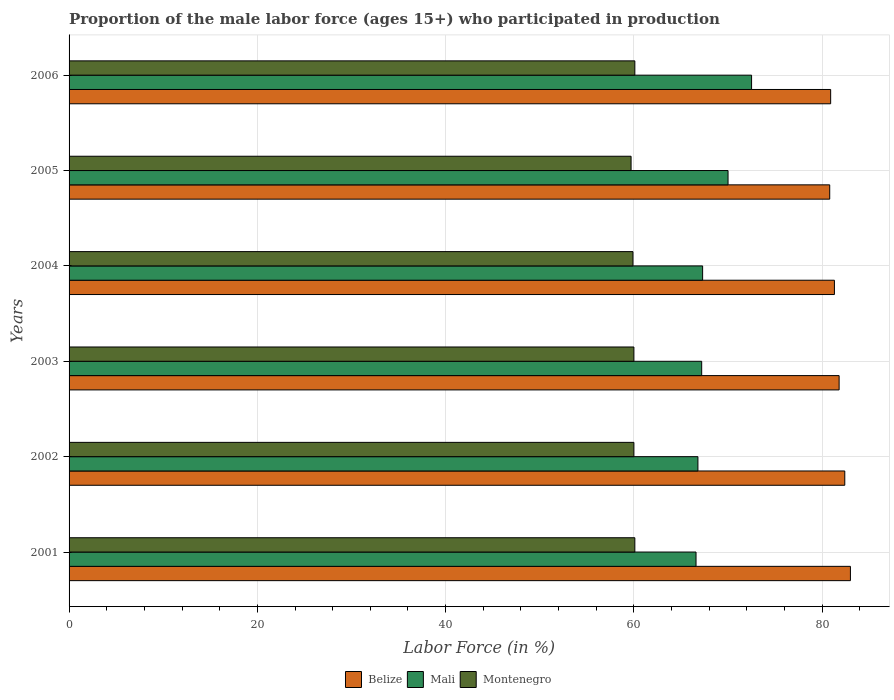Are the number of bars on each tick of the Y-axis equal?
Your response must be concise. Yes. How many bars are there on the 3rd tick from the top?
Give a very brief answer. 3. In how many cases, is the number of bars for a given year not equal to the number of legend labels?
Offer a very short reply. 0. What is the proportion of the male labor force who participated in production in Montenegro in 2005?
Keep it short and to the point. 59.7. Across all years, what is the maximum proportion of the male labor force who participated in production in Mali?
Your answer should be very brief. 72.5. Across all years, what is the minimum proportion of the male labor force who participated in production in Montenegro?
Your answer should be compact. 59.7. In which year was the proportion of the male labor force who participated in production in Belize maximum?
Your answer should be very brief. 2001. In which year was the proportion of the male labor force who participated in production in Belize minimum?
Keep it short and to the point. 2005. What is the total proportion of the male labor force who participated in production in Montenegro in the graph?
Provide a succinct answer. 359.8. What is the difference between the proportion of the male labor force who participated in production in Mali in 2002 and that in 2003?
Offer a terse response. -0.4. What is the difference between the proportion of the male labor force who participated in production in Mali in 2003 and the proportion of the male labor force who participated in production in Belize in 2002?
Provide a short and direct response. -15.2. What is the average proportion of the male labor force who participated in production in Belize per year?
Keep it short and to the point. 81.7. In the year 2004, what is the difference between the proportion of the male labor force who participated in production in Mali and proportion of the male labor force who participated in production in Belize?
Keep it short and to the point. -14. In how many years, is the proportion of the male labor force who participated in production in Mali greater than 40 %?
Give a very brief answer. 6. What is the ratio of the proportion of the male labor force who participated in production in Mali in 2003 to that in 2004?
Offer a very short reply. 1. Is the proportion of the male labor force who participated in production in Mali in 2001 less than that in 2004?
Provide a succinct answer. Yes. What is the difference between the highest and the second highest proportion of the male labor force who participated in production in Montenegro?
Provide a succinct answer. 0. What is the difference between the highest and the lowest proportion of the male labor force who participated in production in Montenegro?
Ensure brevity in your answer.  0.4. In how many years, is the proportion of the male labor force who participated in production in Montenegro greater than the average proportion of the male labor force who participated in production in Montenegro taken over all years?
Provide a short and direct response. 4. What does the 1st bar from the top in 2005 represents?
Offer a very short reply. Montenegro. What does the 3rd bar from the bottom in 2001 represents?
Offer a terse response. Montenegro. How many years are there in the graph?
Offer a very short reply. 6. How are the legend labels stacked?
Keep it short and to the point. Horizontal. What is the title of the graph?
Offer a terse response. Proportion of the male labor force (ages 15+) who participated in production. What is the label or title of the X-axis?
Provide a short and direct response. Labor Force (in %). What is the Labor Force (in %) of Mali in 2001?
Keep it short and to the point. 66.6. What is the Labor Force (in %) of Montenegro in 2001?
Keep it short and to the point. 60.1. What is the Labor Force (in %) of Belize in 2002?
Your answer should be very brief. 82.4. What is the Labor Force (in %) in Mali in 2002?
Keep it short and to the point. 66.8. What is the Labor Force (in %) of Belize in 2003?
Give a very brief answer. 81.8. What is the Labor Force (in %) in Mali in 2003?
Give a very brief answer. 67.2. What is the Labor Force (in %) in Belize in 2004?
Provide a succinct answer. 81.3. What is the Labor Force (in %) in Mali in 2004?
Make the answer very short. 67.3. What is the Labor Force (in %) in Montenegro in 2004?
Your response must be concise. 59.9. What is the Labor Force (in %) in Belize in 2005?
Offer a terse response. 80.8. What is the Labor Force (in %) in Montenegro in 2005?
Make the answer very short. 59.7. What is the Labor Force (in %) in Belize in 2006?
Provide a succinct answer. 80.9. What is the Labor Force (in %) of Mali in 2006?
Provide a succinct answer. 72.5. What is the Labor Force (in %) in Montenegro in 2006?
Offer a very short reply. 60.1. Across all years, what is the maximum Labor Force (in %) in Belize?
Give a very brief answer. 83. Across all years, what is the maximum Labor Force (in %) of Mali?
Provide a succinct answer. 72.5. Across all years, what is the maximum Labor Force (in %) in Montenegro?
Provide a short and direct response. 60.1. Across all years, what is the minimum Labor Force (in %) of Belize?
Keep it short and to the point. 80.8. Across all years, what is the minimum Labor Force (in %) of Mali?
Offer a very short reply. 66.6. Across all years, what is the minimum Labor Force (in %) of Montenegro?
Offer a terse response. 59.7. What is the total Labor Force (in %) in Belize in the graph?
Provide a succinct answer. 490.2. What is the total Labor Force (in %) in Mali in the graph?
Offer a terse response. 410.4. What is the total Labor Force (in %) in Montenegro in the graph?
Your answer should be very brief. 359.8. What is the difference between the Labor Force (in %) in Mali in 2001 and that in 2002?
Ensure brevity in your answer.  -0.2. What is the difference between the Labor Force (in %) of Belize in 2001 and that in 2003?
Your answer should be compact. 1.2. What is the difference between the Labor Force (in %) of Mali in 2001 and that in 2003?
Offer a very short reply. -0.6. What is the difference between the Labor Force (in %) in Mali in 2001 and that in 2004?
Give a very brief answer. -0.7. What is the difference between the Labor Force (in %) in Belize in 2001 and that in 2005?
Give a very brief answer. 2.2. What is the difference between the Labor Force (in %) in Mali in 2001 and that in 2005?
Give a very brief answer. -3.4. What is the difference between the Labor Force (in %) of Mali in 2001 and that in 2006?
Provide a short and direct response. -5.9. What is the difference between the Labor Force (in %) of Montenegro in 2001 and that in 2006?
Your answer should be very brief. 0. What is the difference between the Labor Force (in %) in Belize in 2002 and that in 2005?
Your answer should be very brief. 1.6. What is the difference between the Labor Force (in %) of Mali in 2002 and that in 2006?
Make the answer very short. -5.7. What is the difference between the Labor Force (in %) in Montenegro in 2002 and that in 2006?
Offer a terse response. -0.1. What is the difference between the Labor Force (in %) of Mali in 2003 and that in 2004?
Offer a terse response. -0.1. What is the difference between the Labor Force (in %) in Montenegro in 2003 and that in 2004?
Give a very brief answer. 0.1. What is the difference between the Labor Force (in %) in Belize in 2003 and that in 2005?
Provide a succinct answer. 1. What is the difference between the Labor Force (in %) of Montenegro in 2003 and that in 2005?
Provide a short and direct response. 0.3. What is the difference between the Labor Force (in %) of Belize in 2003 and that in 2006?
Your answer should be very brief. 0.9. What is the difference between the Labor Force (in %) of Belize in 2004 and that in 2005?
Offer a terse response. 0.5. What is the difference between the Labor Force (in %) of Mali in 2004 and that in 2005?
Give a very brief answer. -2.7. What is the difference between the Labor Force (in %) of Belize in 2004 and that in 2006?
Your response must be concise. 0.4. What is the difference between the Labor Force (in %) in Montenegro in 2005 and that in 2006?
Offer a very short reply. -0.4. What is the difference between the Labor Force (in %) of Mali in 2001 and the Labor Force (in %) of Montenegro in 2002?
Your answer should be compact. 6.6. What is the difference between the Labor Force (in %) of Belize in 2001 and the Labor Force (in %) of Mali in 2003?
Give a very brief answer. 15.8. What is the difference between the Labor Force (in %) in Belize in 2001 and the Labor Force (in %) in Mali in 2004?
Keep it short and to the point. 15.7. What is the difference between the Labor Force (in %) of Belize in 2001 and the Labor Force (in %) of Montenegro in 2004?
Ensure brevity in your answer.  23.1. What is the difference between the Labor Force (in %) of Mali in 2001 and the Labor Force (in %) of Montenegro in 2004?
Offer a terse response. 6.7. What is the difference between the Labor Force (in %) of Belize in 2001 and the Labor Force (in %) of Mali in 2005?
Your answer should be compact. 13. What is the difference between the Labor Force (in %) of Belize in 2001 and the Labor Force (in %) of Montenegro in 2005?
Make the answer very short. 23.3. What is the difference between the Labor Force (in %) of Belize in 2001 and the Labor Force (in %) of Mali in 2006?
Your response must be concise. 10.5. What is the difference between the Labor Force (in %) of Belize in 2001 and the Labor Force (in %) of Montenegro in 2006?
Ensure brevity in your answer.  22.9. What is the difference between the Labor Force (in %) in Belize in 2002 and the Labor Force (in %) in Mali in 2003?
Make the answer very short. 15.2. What is the difference between the Labor Force (in %) in Belize in 2002 and the Labor Force (in %) in Montenegro in 2003?
Make the answer very short. 22.4. What is the difference between the Labor Force (in %) of Mali in 2002 and the Labor Force (in %) of Montenegro in 2003?
Offer a terse response. 6.8. What is the difference between the Labor Force (in %) of Belize in 2002 and the Labor Force (in %) of Mali in 2004?
Make the answer very short. 15.1. What is the difference between the Labor Force (in %) in Belize in 2002 and the Labor Force (in %) in Montenegro in 2004?
Provide a succinct answer. 22.5. What is the difference between the Labor Force (in %) of Belize in 2002 and the Labor Force (in %) of Mali in 2005?
Your answer should be very brief. 12.4. What is the difference between the Labor Force (in %) in Belize in 2002 and the Labor Force (in %) in Montenegro in 2005?
Provide a short and direct response. 22.7. What is the difference between the Labor Force (in %) of Mali in 2002 and the Labor Force (in %) of Montenegro in 2005?
Your answer should be compact. 7.1. What is the difference between the Labor Force (in %) in Belize in 2002 and the Labor Force (in %) in Mali in 2006?
Offer a very short reply. 9.9. What is the difference between the Labor Force (in %) in Belize in 2002 and the Labor Force (in %) in Montenegro in 2006?
Provide a succinct answer. 22.3. What is the difference between the Labor Force (in %) in Mali in 2002 and the Labor Force (in %) in Montenegro in 2006?
Provide a succinct answer. 6.7. What is the difference between the Labor Force (in %) in Belize in 2003 and the Labor Force (in %) in Montenegro in 2004?
Give a very brief answer. 21.9. What is the difference between the Labor Force (in %) in Mali in 2003 and the Labor Force (in %) in Montenegro in 2004?
Your answer should be very brief. 7.3. What is the difference between the Labor Force (in %) in Belize in 2003 and the Labor Force (in %) in Montenegro in 2005?
Provide a short and direct response. 22.1. What is the difference between the Labor Force (in %) in Belize in 2003 and the Labor Force (in %) in Mali in 2006?
Ensure brevity in your answer.  9.3. What is the difference between the Labor Force (in %) of Belize in 2003 and the Labor Force (in %) of Montenegro in 2006?
Provide a short and direct response. 21.7. What is the difference between the Labor Force (in %) of Belize in 2004 and the Labor Force (in %) of Montenegro in 2005?
Give a very brief answer. 21.6. What is the difference between the Labor Force (in %) in Belize in 2004 and the Labor Force (in %) in Montenegro in 2006?
Ensure brevity in your answer.  21.2. What is the difference between the Labor Force (in %) of Mali in 2004 and the Labor Force (in %) of Montenegro in 2006?
Provide a succinct answer. 7.2. What is the difference between the Labor Force (in %) in Belize in 2005 and the Labor Force (in %) in Montenegro in 2006?
Give a very brief answer. 20.7. What is the difference between the Labor Force (in %) of Mali in 2005 and the Labor Force (in %) of Montenegro in 2006?
Give a very brief answer. 9.9. What is the average Labor Force (in %) of Belize per year?
Offer a terse response. 81.7. What is the average Labor Force (in %) of Mali per year?
Give a very brief answer. 68.4. What is the average Labor Force (in %) in Montenegro per year?
Offer a very short reply. 59.97. In the year 2001, what is the difference between the Labor Force (in %) in Belize and Labor Force (in %) in Montenegro?
Offer a terse response. 22.9. In the year 2002, what is the difference between the Labor Force (in %) in Belize and Labor Force (in %) in Montenegro?
Offer a very short reply. 22.4. In the year 2002, what is the difference between the Labor Force (in %) in Mali and Labor Force (in %) in Montenegro?
Your response must be concise. 6.8. In the year 2003, what is the difference between the Labor Force (in %) in Belize and Labor Force (in %) in Montenegro?
Provide a short and direct response. 21.8. In the year 2003, what is the difference between the Labor Force (in %) of Mali and Labor Force (in %) of Montenegro?
Offer a terse response. 7.2. In the year 2004, what is the difference between the Labor Force (in %) of Belize and Labor Force (in %) of Montenegro?
Your response must be concise. 21.4. In the year 2005, what is the difference between the Labor Force (in %) in Belize and Labor Force (in %) in Mali?
Offer a terse response. 10.8. In the year 2005, what is the difference between the Labor Force (in %) of Belize and Labor Force (in %) of Montenegro?
Provide a succinct answer. 21.1. In the year 2005, what is the difference between the Labor Force (in %) in Mali and Labor Force (in %) in Montenegro?
Your answer should be compact. 10.3. In the year 2006, what is the difference between the Labor Force (in %) in Belize and Labor Force (in %) in Mali?
Offer a very short reply. 8.4. In the year 2006, what is the difference between the Labor Force (in %) of Belize and Labor Force (in %) of Montenegro?
Your answer should be compact. 20.8. What is the ratio of the Labor Force (in %) of Belize in 2001 to that in 2002?
Give a very brief answer. 1.01. What is the ratio of the Labor Force (in %) of Mali in 2001 to that in 2002?
Keep it short and to the point. 1. What is the ratio of the Labor Force (in %) of Montenegro in 2001 to that in 2002?
Offer a terse response. 1. What is the ratio of the Labor Force (in %) in Belize in 2001 to that in 2003?
Provide a short and direct response. 1.01. What is the ratio of the Labor Force (in %) in Belize in 2001 to that in 2004?
Your answer should be compact. 1.02. What is the ratio of the Labor Force (in %) in Montenegro in 2001 to that in 2004?
Provide a succinct answer. 1. What is the ratio of the Labor Force (in %) of Belize in 2001 to that in 2005?
Your answer should be very brief. 1.03. What is the ratio of the Labor Force (in %) in Mali in 2001 to that in 2005?
Your answer should be very brief. 0.95. What is the ratio of the Labor Force (in %) in Montenegro in 2001 to that in 2005?
Your answer should be very brief. 1.01. What is the ratio of the Labor Force (in %) of Mali in 2001 to that in 2006?
Provide a short and direct response. 0.92. What is the ratio of the Labor Force (in %) in Montenegro in 2001 to that in 2006?
Ensure brevity in your answer.  1. What is the ratio of the Labor Force (in %) of Belize in 2002 to that in 2003?
Give a very brief answer. 1.01. What is the ratio of the Labor Force (in %) of Mali in 2002 to that in 2003?
Your answer should be very brief. 0.99. What is the ratio of the Labor Force (in %) in Belize in 2002 to that in 2004?
Give a very brief answer. 1.01. What is the ratio of the Labor Force (in %) in Belize in 2002 to that in 2005?
Give a very brief answer. 1.02. What is the ratio of the Labor Force (in %) of Mali in 2002 to that in 2005?
Give a very brief answer. 0.95. What is the ratio of the Labor Force (in %) of Montenegro in 2002 to that in 2005?
Your answer should be very brief. 1. What is the ratio of the Labor Force (in %) of Belize in 2002 to that in 2006?
Keep it short and to the point. 1.02. What is the ratio of the Labor Force (in %) in Mali in 2002 to that in 2006?
Your response must be concise. 0.92. What is the ratio of the Labor Force (in %) in Montenegro in 2002 to that in 2006?
Keep it short and to the point. 1. What is the ratio of the Labor Force (in %) of Montenegro in 2003 to that in 2004?
Provide a short and direct response. 1. What is the ratio of the Labor Force (in %) in Belize in 2003 to that in 2005?
Offer a very short reply. 1.01. What is the ratio of the Labor Force (in %) of Mali in 2003 to that in 2005?
Your answer should be compact. 0.96. What is the ratio of the Labor Force (in %) in Belize in 2003 to that in 2006?
Offer a terse response. 1.01. What is the ratio of the Labor Force (in %) of Mali in 2003 to that in 2006?
Your answer should be very brief. 0.93. What is the ratio of the Labor Force (in %) of Montenegro in 2003 to that in 2006?
Provide a short and direct response. 1. What is the ratio of the Labor Force (in %) in Belize in 2004 to that in 2005?
Make the answer very short. 1.01. What is the ratio of the Labor Force (in %) of Mali in 2004 to that in 2005?
Your answer should be compact. 0.96. What is the ratio of the Labor Force (in %) of Montenegro in 2004 to that in 2005?
Your answer should be compact. 1. What is the ratio of the Labor Force (in %) in Belize in 2004 to that in 2006?
Offer a very short reply. 1. What is the ratio of the Labor Force (in %) in Mali in 2004 to that in 2006?
Ensure brevity in your answer.  0.93. What is the ratio of the Labor Force (in %) of Belize in 2005 to that in 2006?
Your answer should be very brief. 1. What is the ratio of the Labor Force (in %) of Mali in 2005 to that in 2006?
Offer a very short reply. 0.97. What is the difference between the highest and the lowest Labor Force (in %) of Mali?
Make the answer very short. 5.9. 